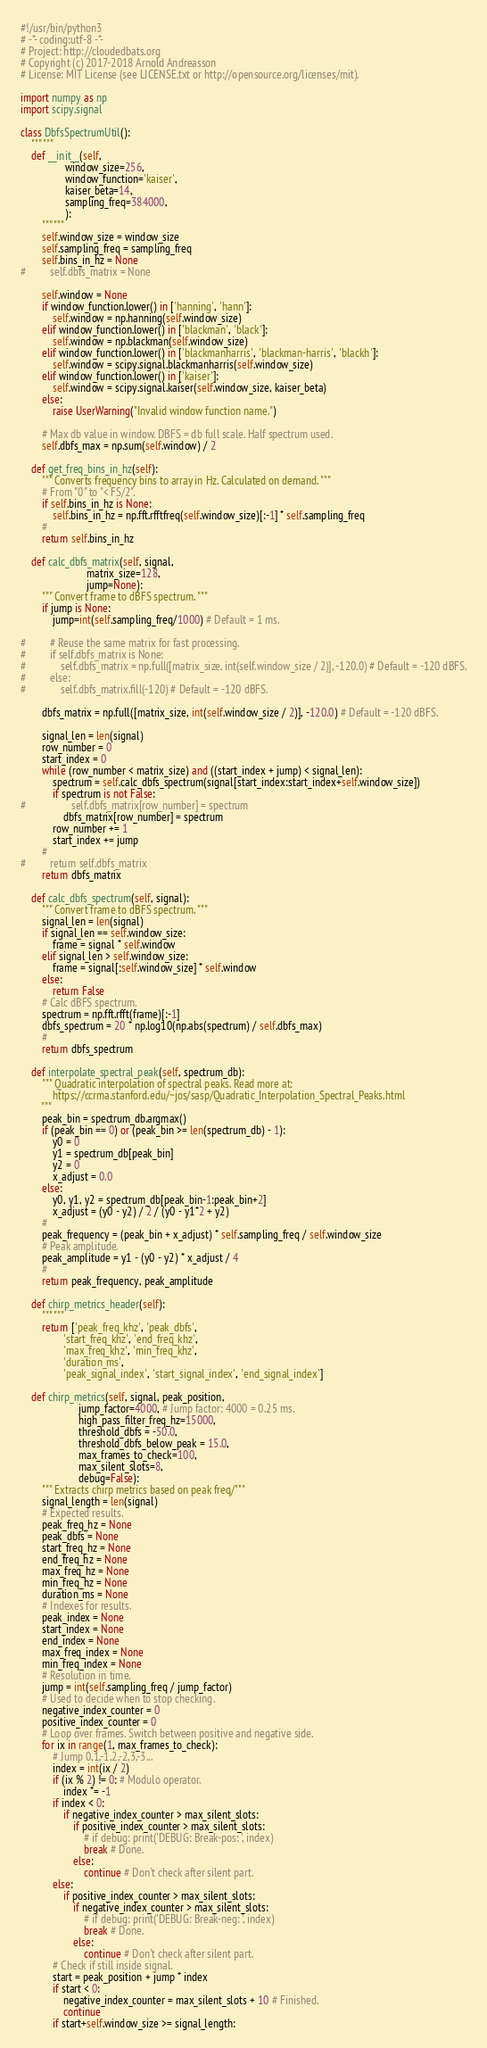<code> <loc_0><loc_0><loc_500><loc_500><_Python_>#!/usr/bin/python3
# -*- coding:utf-8 -*-
# Project: http://cloudedbats.org
# Copyright (c) 2017-2018 Arnold Andreasson 
# License: MIT License (see LICENSE.txt or http://opensource.org/licenses/mit).

import numpy as np
import scipy.signal

class DbfsSpectrumUtil():
    """ """
    def __init__(self, 
                 window_size=256,
                 window_function='kaiser',
                 kaiser_beta=14,
                 sampling_freq=384000,
                 ):
        """ """
        self.window_size = window_size
        self.sampling_freq = sampling_freq
        self.bins_in_hz = None
#         self.dbfs_matrix = None
        
        self.window = None
        if window_function.lower() in ['hanning', 'hann']:
            self.window = np.hanning(self.window_size)
        elif window_function.lower() in ['blackman', 'black']:
            self.window = np.blackman(self.window_size)
        elif window_function.lower() in ['blackmanharris', 'blackman-harris', 'blackh']:
            self.window = scipy.signal.blackmanharris(self.window_size)
        elif window_function.lower() in ['kaiser']:
            self.window = scipy.signal.kaiser(self.window_size, kaiser_beta)
        else:
            raise UserWarning("Invalid window function name.")

        # Max db value in window. DBFS = db full scale. Half spectrum used.
        self.dbfs_max = np.sum(self.window) / 2 

    def get_freq_bins_in_hz(self):
        """ Converts frequency bins to array in Hz. Calculated on demand. """
        # From "0" to "< FS/2".
        if self.bins_in_hz is None:      
            self.bins_in_hz = np.fft.rfftfreq(self.window_size)[:-1] * self.sampling_freq
        #
        return self.bins_in_hz

    def calc_dbfs_matrix(self, signal, 
                         matrix_size=128, 
                         jump=None):
        """ Convert frame to dBFS spectrum. """
        if jump is None:
            jump=int(self.sampling_freq/1000) # Default = 1 ms.
            
#         # Reuse the same matrix for fast processing.
#         if self.dbfs_matrix is None:
#             self.dbfs_matrix = np.full([matrix_size, int(self.window_size / 2)], -120.0) # Default = -120 dBFS.
#         else:
#             self.dbfs_matrix.fill(-120) # Default = -120 dBFS.

        dbfs_matrix = np.full([matrix_size, int(self.window_size / 2)], -120.0) # Default = -120 dBFS.

        signal_len = len(signal)      
        row_number = 0
        start_index = 0
        while (row_number < matrix_size) and ((start_index + jump) < signal_len):
            spectrum = self.calc_dbfs_spectrum(signal[start_index:start_index+self.window_size])
            if spectrum is not False:
#                 self.dbfs_matrix[row_number] = spectrum
                dbfs_matrix[row_number] = spectrum
            row_number += 1
            start_index += jump
        #   
#         return self.dbfs_matrix
        return dbfs_matrix

    def calc_dbfs_spectrum(self, signal):
        """ Convert frame to dBFS spectrum. """
        signal_len = len(signal)
        if signal_len == self.window_size:
            frame = signal * self.window
        elif signal_len > self.window_size:
            frame = signal[:self.window_size] * self.window
        else:
            return False
        # Calc dBFS spectrum.
        spectrum = np.fft.rfft(frame)[:-1]
        dbfs_spectrum = 20 * np.log10(np.abs(spectrum) / self.dbfs_max)
        #
        return dbfs_spectrum

    def interpolate_spectral_peak(self, spectrum_db):
        """ Quadratic interpolation of spectral peaks. Read more at:
            https://ccrma.stanford.edu/~jos/sasp/Quadratic_Interpolation_Spectral_Peaks.html
        """
        peak_bin = spectrum_db.argmax()
        if (peak_bin == 0) or (peak_bin >= len(spectrum_db) - 1):
            y0 = 0
            y1 = spectrum_db[peak_bin]
            y2 = 0
            x_adjust = 0.0
        else:
            y0, y1, y2 = spectrum_db[peak_bin-1:peak_bin+2]
            x_adjust = (y0 - y2) / 2 / (y0 - y1*2 + y2)
        # 
        peak_frequency = (peak_bin + x_adjust) * self.sampling_freq / self.window_size
        # Peak amplitude.
        peak_amplitude = y1 - (y0 - y2) * x_adjust / 4
        #
        return peak_frequency, peak_amplitude

    def chirp_metrics_header(self):
        """ """
        return ['peak_freq_khz', 'peak_dbfs', 
                'start_freq_khz', 'end_freq_khz', 
                'max_freq_khz', 'min_freq_khz', 
                'duration_ms', 
                'peak_signal_index', 'start_signal_index', 'end_signal_index']
        
    def chirp_metrics(self, signal, peak_position, 
                      jump_factor=4000, # Jump factor: 4000 = 0.25 ms.
                      high_pass_filter_freq_hz=15000,
                      threshold_dbfs = -50.0, 
                      threshold_dbfs_below_peak = 15.0, 
                      max_frames_to_check=100, 
                      max_silent_slots=8, 
                      debug=False):
        """ Extracts chirp metrics based on peak freq/"""
        signal_length = len(signal)
        # Expected results.
        peak_freq_hz = None
        peak_dbfs = None
        start_freq_hz = None
        end_freq_hz = None
        max_freq_hz = None
        min_freq_hz = None
        duration_ms = None
        # Indexes for results.
        peak_index = None
        start_index = None
        end_index = None
        max_freq_index = None
        min_freq_index = None
        # Resolution in time.
        jump = int(self.sampling_freq / jump_factor)
        # Used to decide when to stop checking.
        negative_index_counter = 0
        positive_index_counter = 0
        # Loop over frames. Switch between positive and negative side.
        for ix in range(1, max_frames_to_check):
            # Jump 0,1,-1,2,-2,3,-3...
            index = int(ix / 2)
            if (ix % 2) != 0: # Modulo operator.
                index *= -1
            if index < 0:
                if negative_index_counter > max_silent_slots:
                    if positive_index_counter > max_silent_slots:
                        # if debug: print('DEBUG: Break-pos: ', index)
                        break # Done.
                    else:
                        continue # Don't check after silent part.
            else:
                if positive_index_counter > max_silent_slots:
                    if negative_index_counter > max_silent_slots:
                        # if debug: print('DEBUG: Break-neg: ', index)
                        break # Done.
                    else:
                        continue # Don't check after silent part.
            # Check if still inside signal.
            start = peak_position + jump * index
            if start < 0:
                negative_index_counter = max_silent_slots + 10 # Finished.
                continue
            if start+self.window_size >= signal_length:</code> 